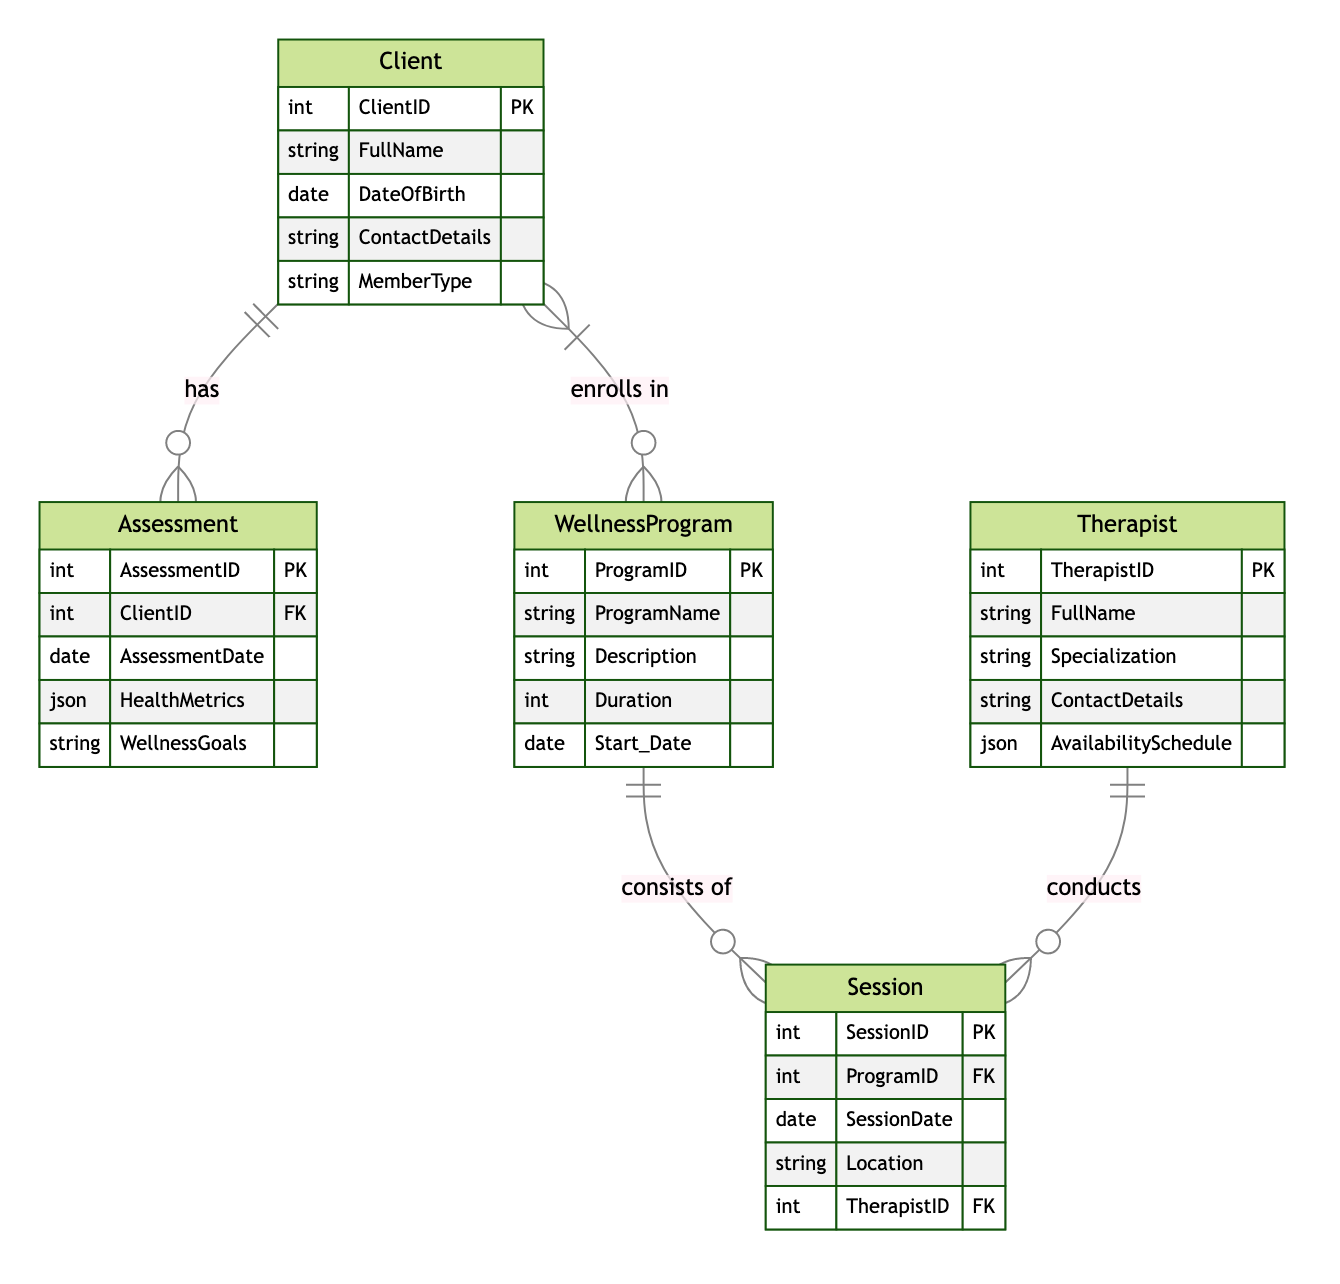What is the primary key of the Client entity? The primary key of the Client entity is indicated directly in the diagram. It is labeled as ClientID, which uniquely identifies each client in the database.
Answer: ClientID How many wellness programs can a client enroll in? The relationship between Client and WellnessProgram is a many-to-many relationship, which means one client can enroll in multiple wellness programs simultaneously.
Answer: Multiple Who conducts the sessions in the wellness program? From the diagram, the entity Therapist is shown to have a relationship with Session, indicating that therapists conduct the sessions associated with wellness programs.
Answer: Therapists What data type is used for the HealthMetrics attribute in the Assessment entity? The diagram specifies that the HealthMetrics attribute is a JSON type. This indicates that it can store structured data in a key-value format.
Answer: JSON How many assessments can a single client have? The relationship Client_Assessment is one-to-many, meaning a single client can have multiple assessments over time, capturing different wellness evaluations.
Answer: Multiple What is the relationship type between WellnessProgram and Session? The diagram indicates that the relationship between WellnessProgram and Session is one-to-many, meaning each wellness program can contain multiple sessions.
Answer: One-to-Many What key identifies each session? Each session in the diagram is uniquely identified by the attribute SessionID, which serves as its primary key.
Answer: SessionID What does the AvailabilitySchedule attribute in the Therapist entity represent? The AvailabilitySchedule attribute provides information on the schedule or times when the therapist is available for conducting sessions. It helps in scheduling programs effectively.
Answer: Availability information How are different wellness goals captured in the Assessment entity? The wellness goals are captured as a string in the WellnessGoals attribute of the Assessment entity. This allows clients to specify their personal aspirations.
Answer: WellnessGoals attribute 